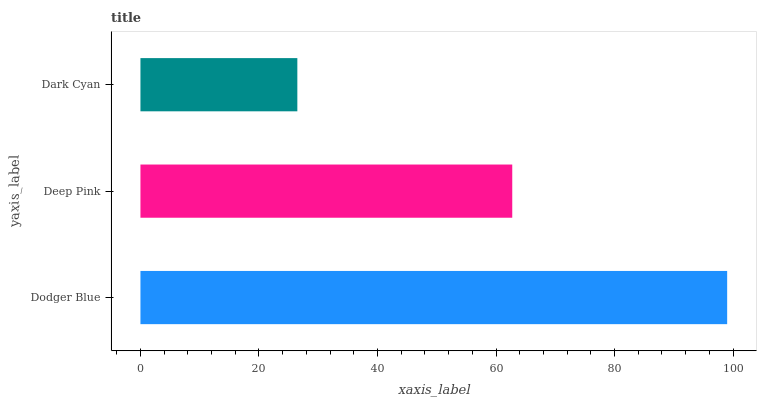Is Dark Cyan the minimum?
Answer yes or no. Yes. Is Dodger Blue the maximum?
Answer yes or no. Yes. Is Deep Pink the minimum?
Answer yes or no. No. Is Deep Pink the maximum?
Answer yes or no. No. Is Dodger Blue greater than Deep Pink?
Answer yes or no. Yes. Is Deep Pink less than Dodger Blue?
Answer yes or no. Yes. Is Deep Pink greater than Dodger Blue?
Answer yes or no. No. Is Dodger Blue less than Deep Pink?
Answer yes or no. No. Is Deep Pink the high median?
Answer yes or no. Yes. Is Deep Pink the low median?
Answer yes or no. Yes. Is Dodger Blue the high median?
Answer yes or no. No. Is Dodger Blue the low median?
Answer yes or no. No. 